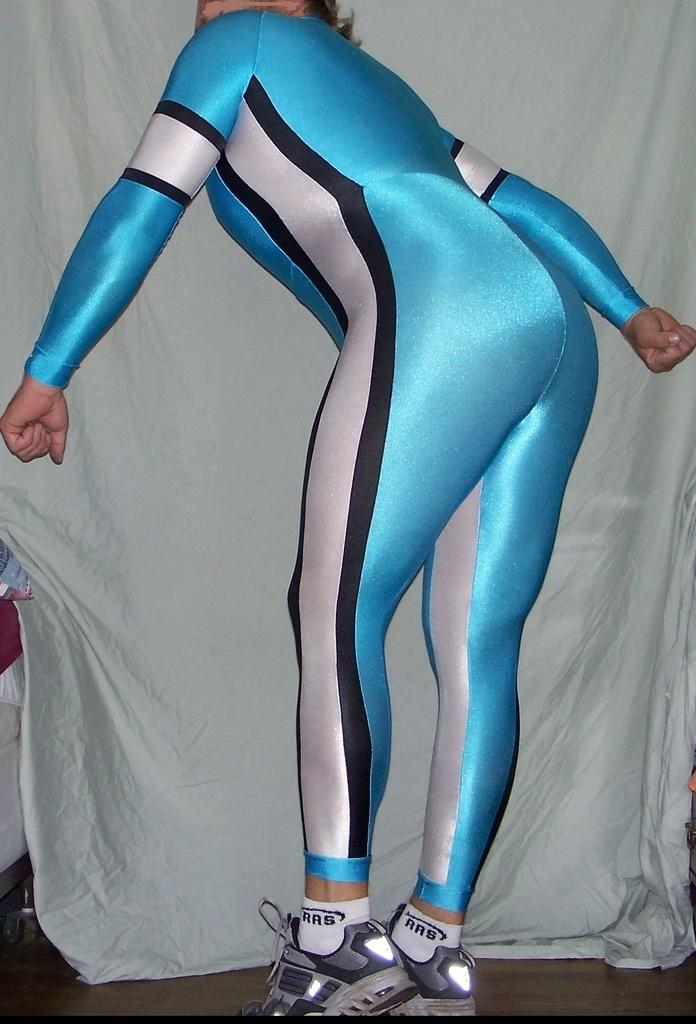Who is present in the image? There is a woman in the image. What is the woman wearing? The woman is wearing a blue dress and shoes. What type of surface is visible in the image? There is a floor visible in the image. What can be seen in the background of the image? There is a white cloth in the background of the image. What is the cause of the fifth root in the image? There is no mention of a fifth root in the image, so it cannot be determined what its cause might be. 